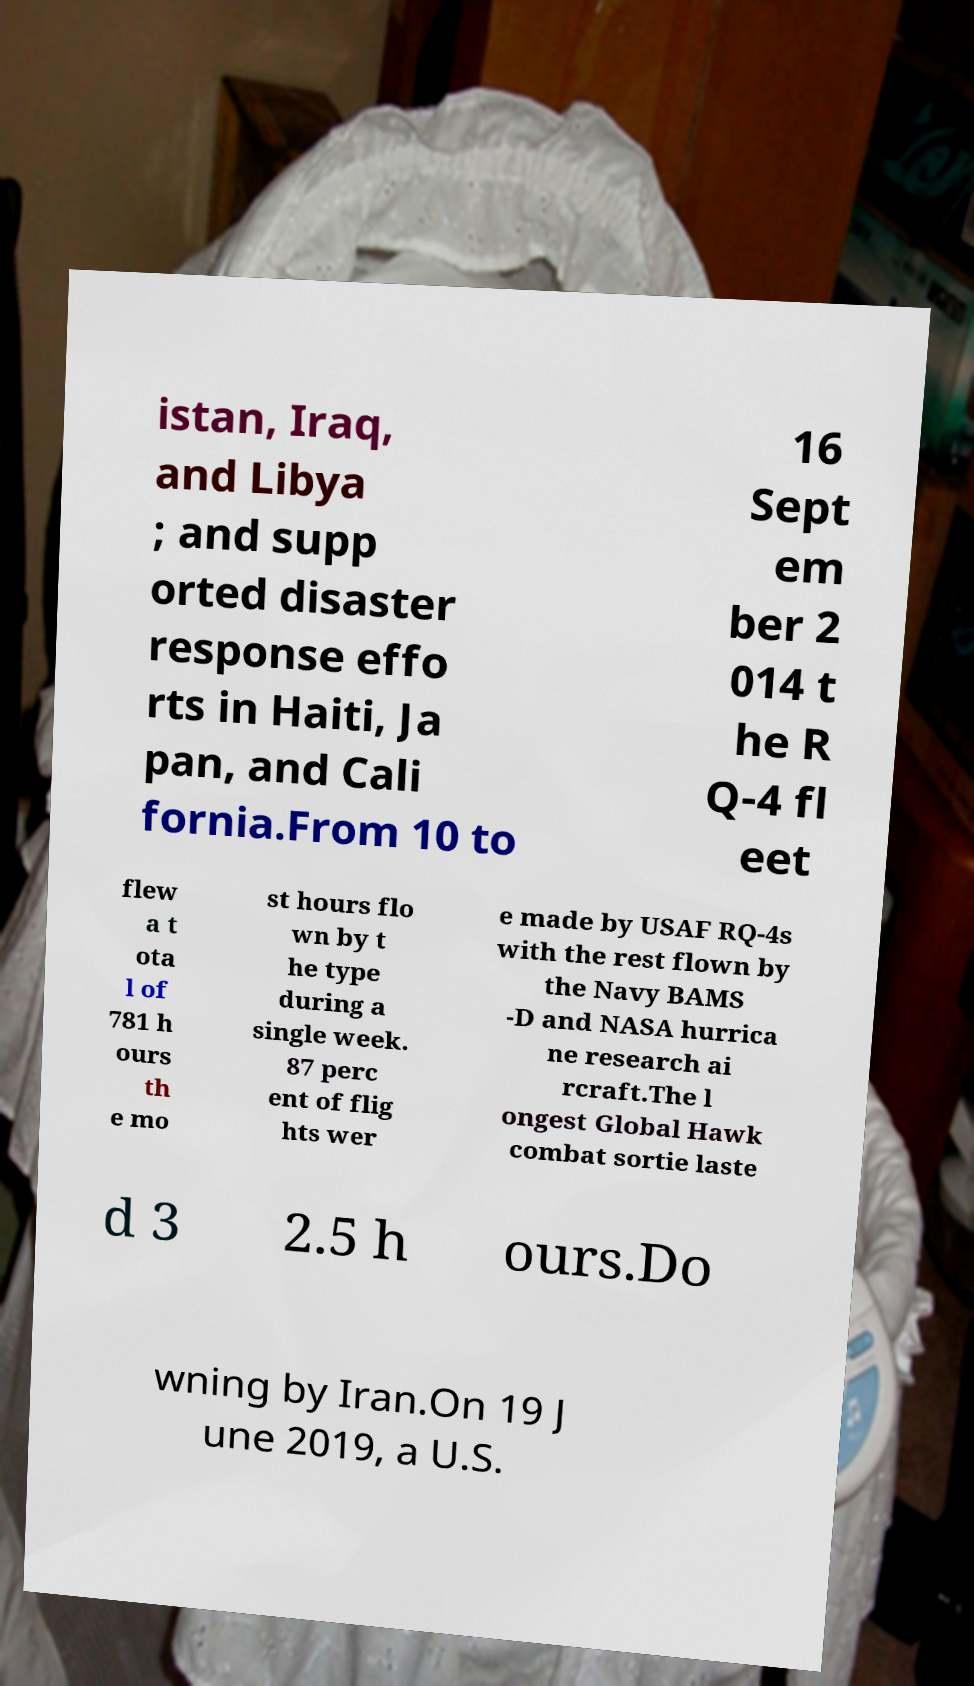Please identify and transcribe the text found in this image. istan, Iraq, and Libya ; and supp orted disaster response effo rts in Haiti, Ja pan, and Cali fornia.From 10 to 16 Sept em ber 2 014 t he R Q-4 fl eet flew a t ota l of 781 h ours th e mo st hours flo wn by t he type during a single week. 87 perc ent of flig hts wer e made by USAF RQ-4s with the rest flown by the Navy BAMS -D and NASA hurrica ne research ai rcraft.The l ongest Global Hawk combat sortie laste d 3 2.5 h ours.Do wning by Iran.On 19 J une 2019, a U.S. 